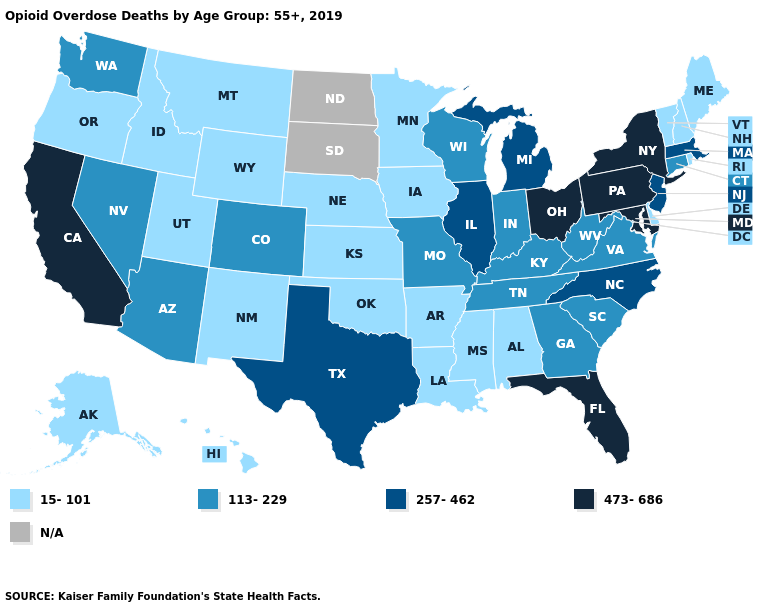Name the states that have a value in the range N/A?
Concise answer only. North Dakota, South Dakota. Name the states that have a value in the range N/A?
Write a very short answer. North Dakota, South Dakota. What is the highest value in states that border Washington?
Concise answer only. 15-101. Name the states that have a value in the range 257-462?
Quick response, please. Illinois, Massachusetts, Michigan, New Jersey, North Carolina, Texas. Name the states that have a value in the range 257-462?
Give a very brief answer. Illinois, Massachusetts, Michigan, New Jersey, North Carolina, Texas. Which states have the lowest value in the West?
Be succinct. Alaska, Hawaii, Idaho, Montana, New Mexico, Oregon, Utah, Wyoming. Does Arkansas have the lowest value in the South?
Keep it brief. Yes. Does the map have missing data?
Be succinct. Yes. Name the states that have a value in the range 15-101?
Write a very short answer. Alabama, Alaska, Arkansas, Delaware, Hawaii, Idaho, Iowa, Kansas, Louisiana, Maine, Minnesota, Mississippi, Montana, Nebraska, New Hampshire, New Mexico, Oklahoma, Oregon, Rhode Island, Utah, Vermont, Wyoming. Name the states that have a value in the range 473-686?
Be succinct. California, Florida, Maryland, New York, Ohio, Pennsylvania. What is the lowest value in the West?
Write a very short answer. 15-101. What is the highest value in states that border Michigan?
Keep it brief. 473-686. Among the states that border Missouri , does Illinois have the lowest value?
Concise answer only. No. Which states have the highest value in the USA?
Quick response, please. California, Florida, Maryland, New York, Ohio, Pennsylvania. How many symbols are there in the legend?
Be succinct. 5. 